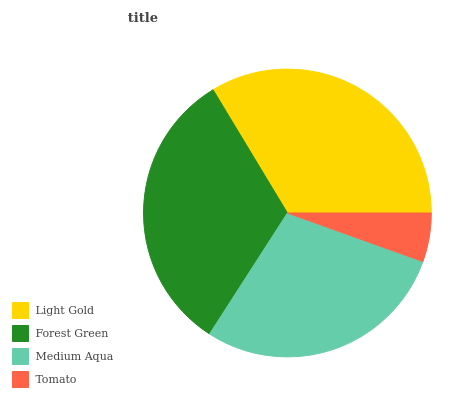Is Tomato the minimum?
Answer yes or no. Yes. Is Light Gold the maximum?
Answer yes or no. Yes. Is Forest Green the minimum?
Answer yes or no. No. Is Forest Green the maximum?
Answer yes or no. No. Is Light Gold greater than Forest Green?
Answer yes or no. Yes. Is Forest Green less than Light Gold?
Answer yes or no. Yes. Is Forest Green greater than Light Gold?
Answer yes or no. No. Is Light Gold less than Forest Green?
Answer yes or no. No. Is Forest Green the high median?
Answer yes or no. Yes. Is Medium Aqua the low median?
Answer yes or no. Yes. Is Medium Aqua the high median?
Answer yes or no. No. Is Light Gold the low median?
Answer yes or no. No. 